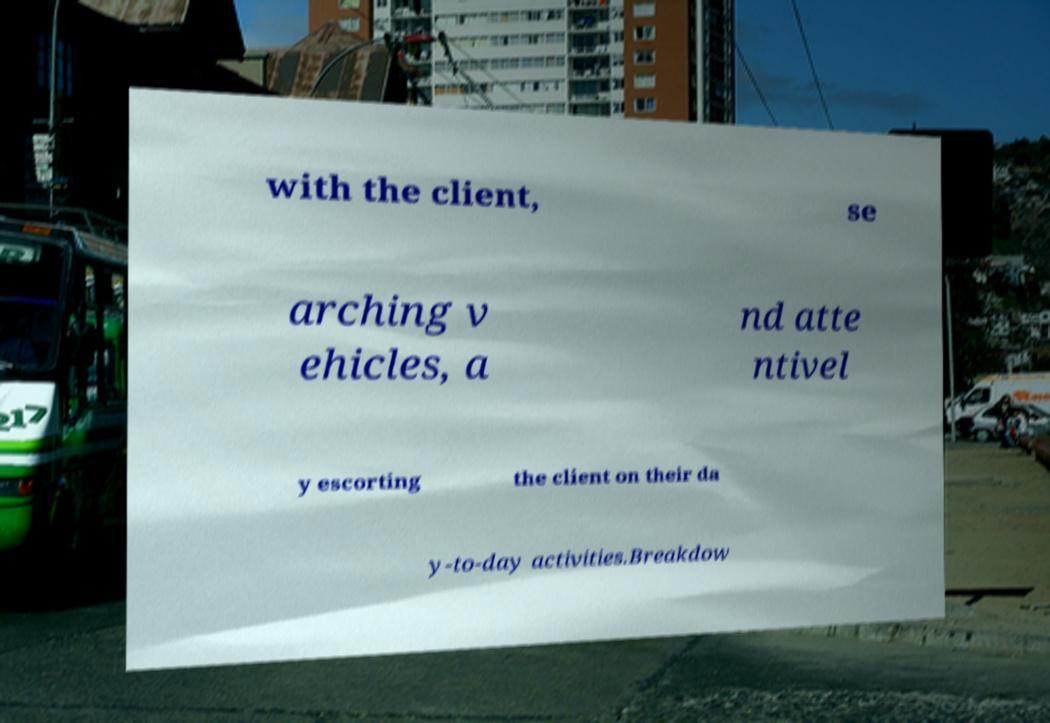Could you assist in decoding the text presented in this image and type it out clearly? with the client, se arching v ehicles, a nd atte ntivel y escorting the client on their da y-to-day activities.Breakdow 